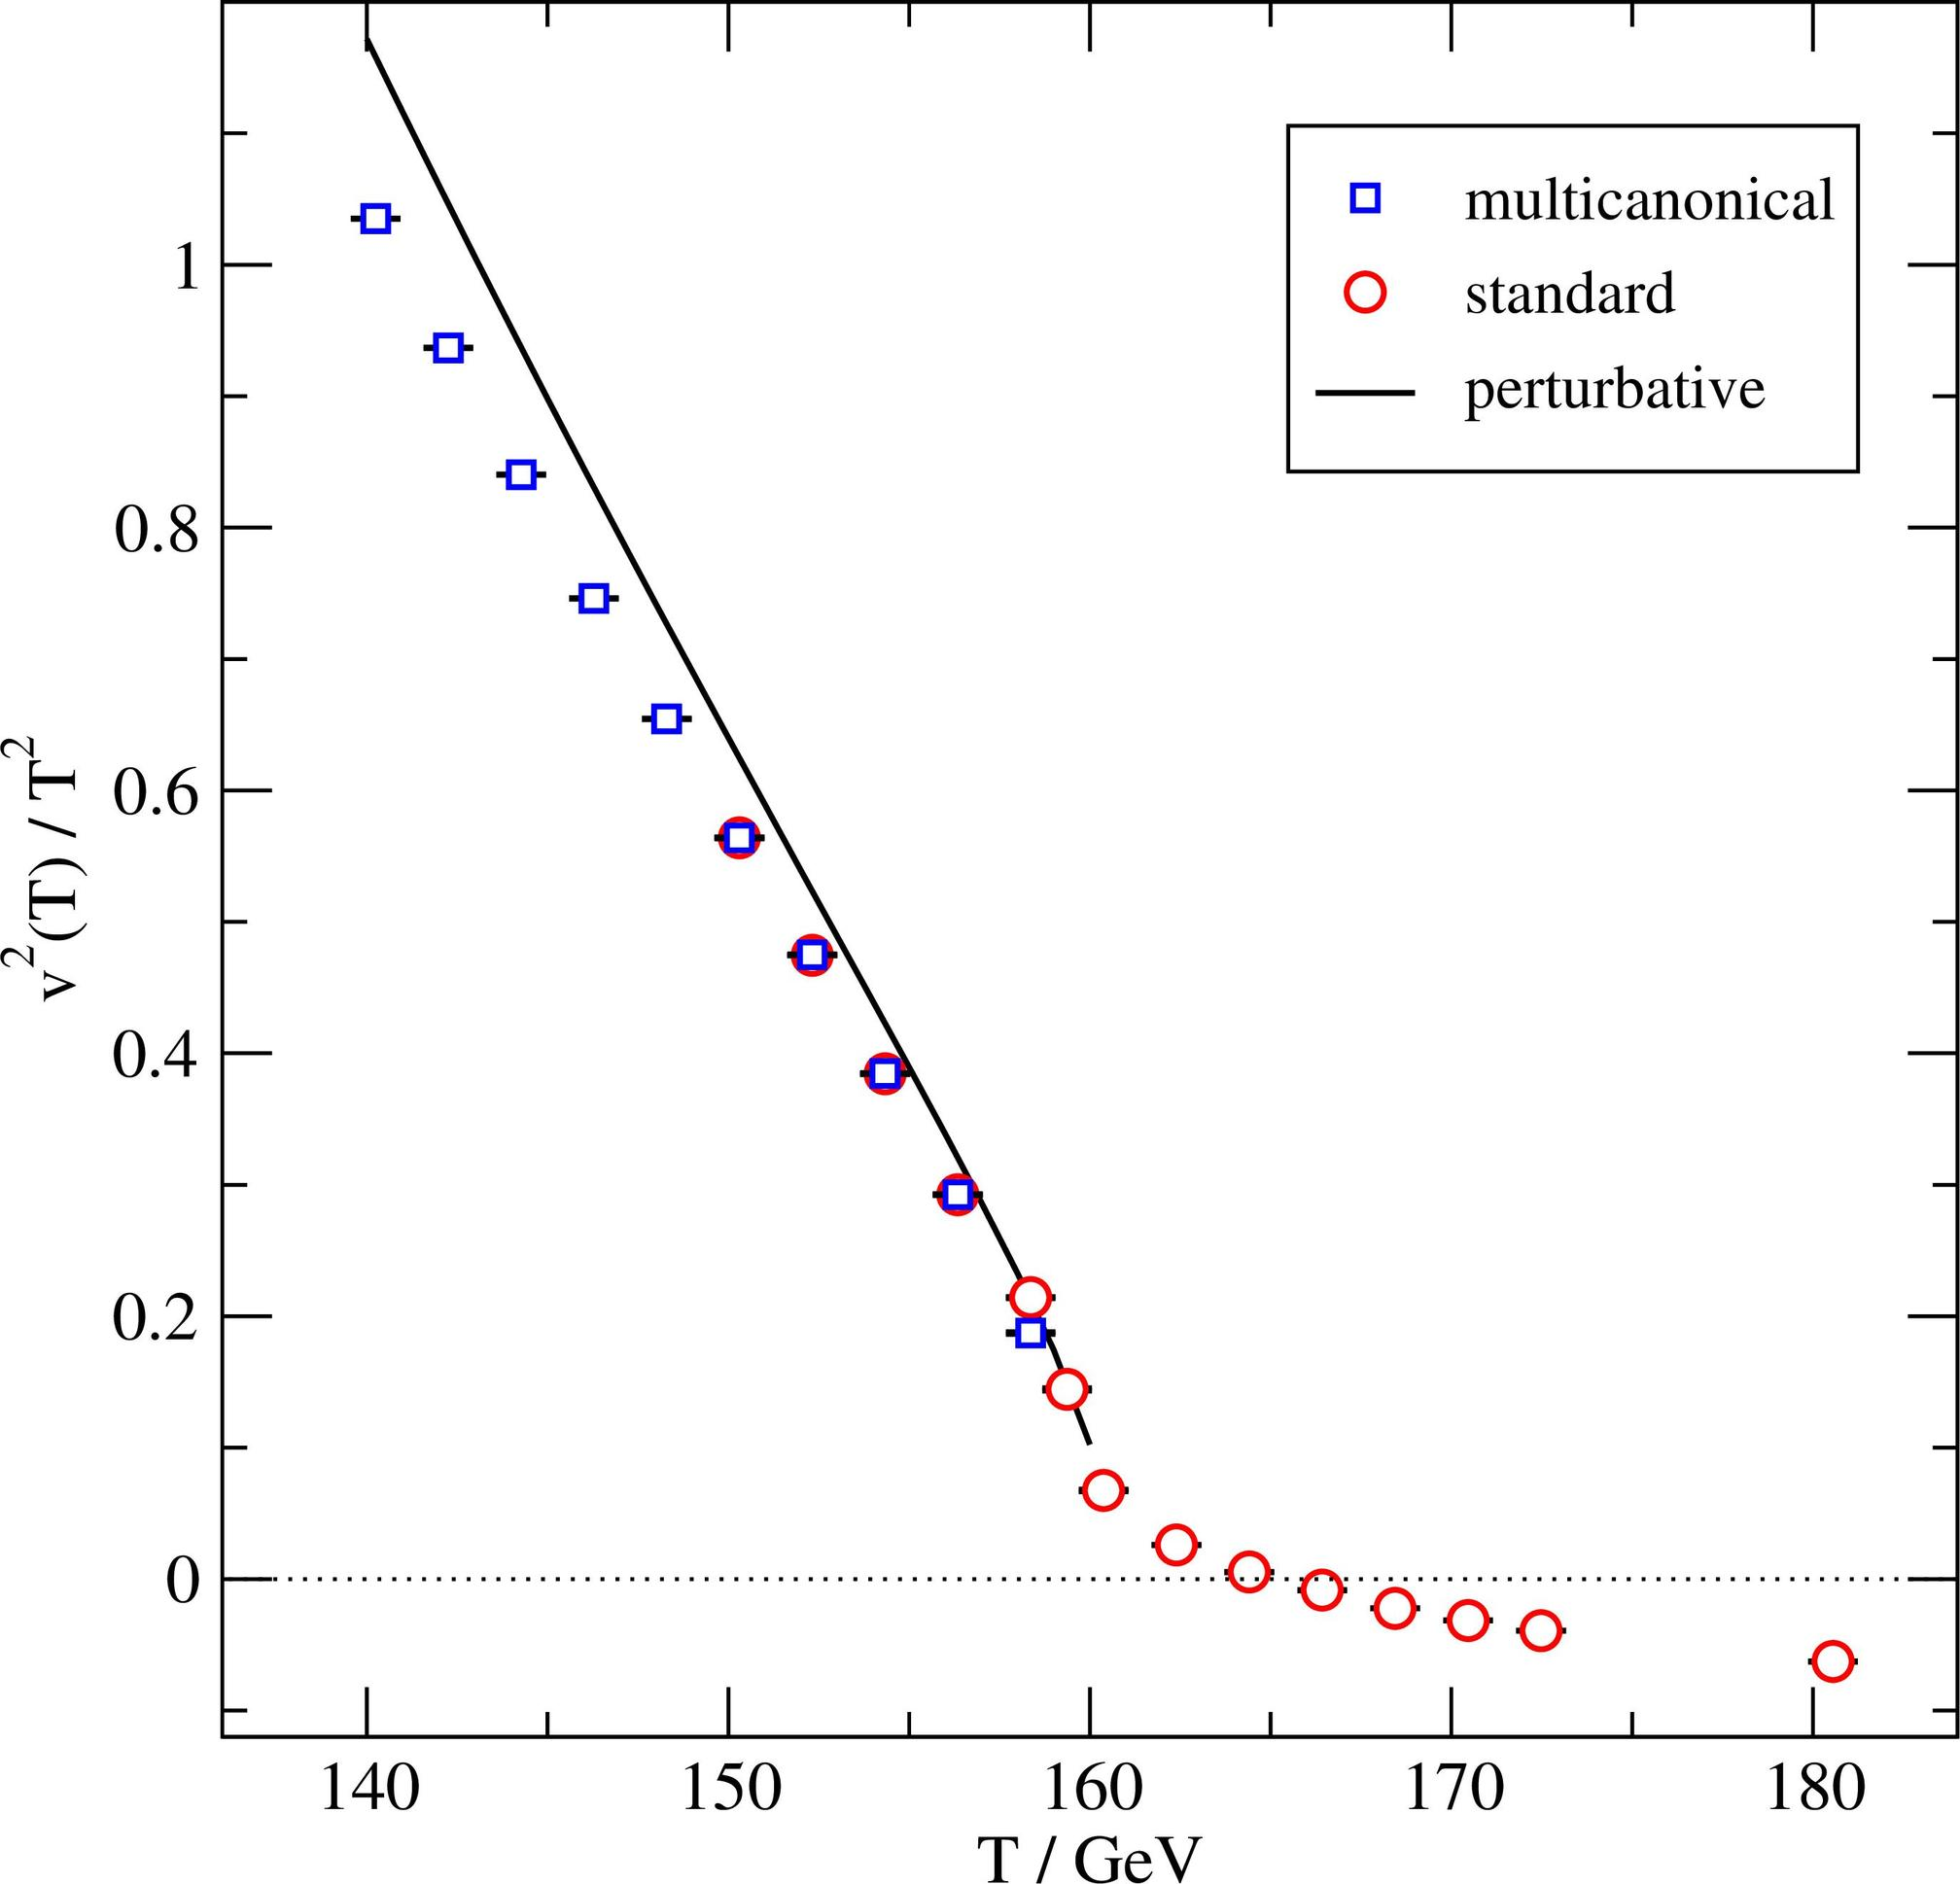Based on the figure, at what temperature range does the discrepancy between the multicanonical and standard measurements become most pronounced? A. 140-150 GeV B. 150-160 GeV C. 160-170 GeV D. 170-180 GeV The graph shows the multicanonical measurements (represented by blue squares) and the standard measurements (depicted as red circles) across various temperature ranges measured in GeV. The greatest discrepancy between these two sets of data appears in the temperature range of 160-170 GeV. In this range, the blue squares diverge significantly from the red circles as well as from the theoretical perturbative curve. This indicates that in this temperature span, the multicanonical measurements deviate most sharply from the standard ones, marking it as the area of highest inconsistency. Therefore, the correct answer is option C. Understanding these discrepancies is crucial for refining theoretical models and improving experimental approaches in the study of particle physics. 